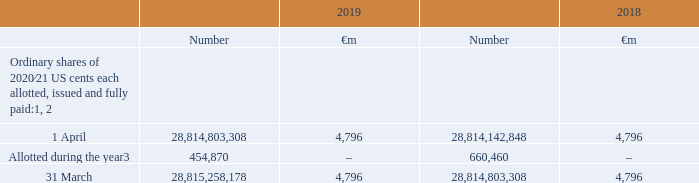17. Called up share capital
Called up share capital is the number of shares in issue at their par value. A number of shares were allotted during the year in relation to employee share schemes.
Accounting policies
Equity instruments issued by the Group are recorded at the amount of the proceeds received, net of direct issuance costs.
Notes: 1 At 31 March 2019 the Group held 1,584,882,610 (2018: 2,139,038,029) treasury shares with a nominal value of €264 million (2018: €356 million). The market value of shares held was €2,566 million (2018: €4,738 million). During the year, 45,657,750 (2018: 53,026,317) treasury shares were reissued under Group share schemes. On 25 August 2017, 729,077,001 treasury shares were issued in settlement of tranche 1 of a maturing subordinated mandatory convertible bond issued on 19 February 2016. On 25 February 2019, 799,067,749 treasury shares were issued in settlement of tranche 2 of the maturing subordinated mandatory convertible bond.
2 On 5 March 2019 the Group announced the placing of subordinated mandatory convertible bonds totalling £1.72 billion with a 2 year maturity date in 2021 and £1.72 billion with a 3 year maturity date due in 2022. The bonds are convertible into a total of 2,547,204,739 ordinary shares with a conversion price of £1.3505 per share.
3 Represents US share awards and option scheme awards.
Which financial years' information is shown in the table? 2018, 2019. What is called up share capital? Number of shares in issue at their par value. How many ordinary shares were allotted during 2019? 454,870. Between 2018 and 2019, which year had more ordinary shares allotted? 660,460>454,870
Answer: 2018. Between 2018 and 2019, which year had more ordinary shares as at 1 April? 28,814,803,308>28,814,142,848
Answer: 2019. What is the average number of ordinary shares as at 31 March for 2018 and 2019? (28,815,258,178+28,814,803,308)/2
Answer: 28815030743. 